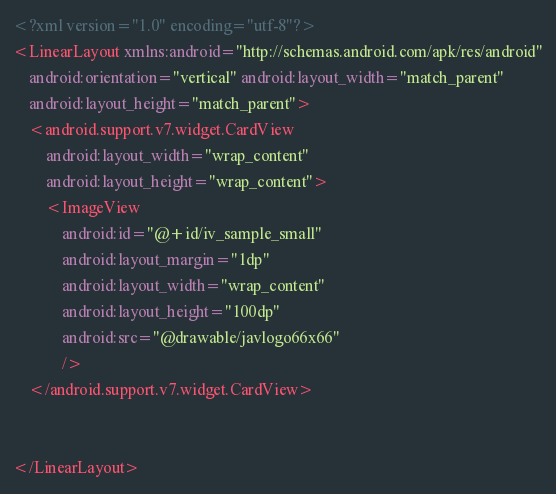<code> <loc_0><loc_0><loc_500><loc_500><_XML_><?xml version="1.0" encoding="utf-8"?>
<LinearLayout xmlns:android="http://schemas.android.com/apk/res/android"
    android:orientation="vertical" android:layout_width="match_parent"
    android:layout_height="match_parent">
    <android.support.v7.widget.CardView
        android:layout_width="wrap_content"
        android:layout_height="wrap_content">
        <ImageView
            android:id="@+id/iv_sample_small"
            android:layout_margin="1dp"
            android:layout_width="wrap_content"
            android:layout_height="100dp"
            android:src="@drawable/javlogo66x66"
            />
    </android.support.v7.widget.CardView>


</LinearLayout></code> 